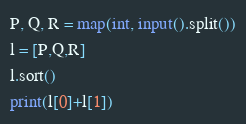<code> <loc_0><loc_0><loc_500><loc_500><_Python_>P, Q, R = map(int, input().split())
l = [P,Q,R]
l.sort()
print(l[0]+l[1])</code> 